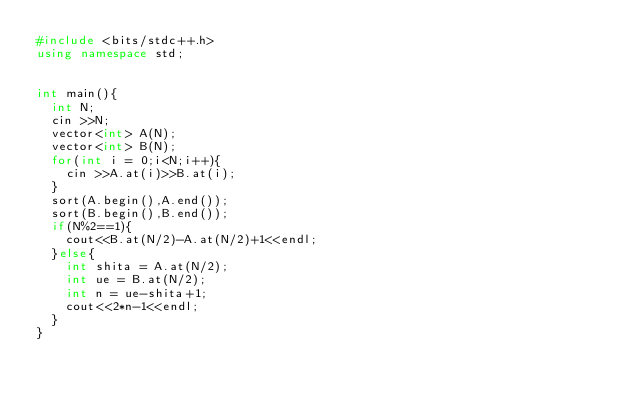Convert code to text. <code><loc_0><loc_0><loc_500><loc_500><_C++_>#include <bits/stdc++.h>
using namespace std;


int main(){
  int N;
  cin >>N;
  vector<int> A(N);
  vector<int> B(N);
  for(int i = 0;i<N;i++){
    cin >>A.at(i)>>B.at(i);
  }
  sort(A.begin(),A.end());
  sort(B.begin(),B.end());
  if(N%2==1){
    cout<<B.at(N/2)-A.at(N/2)+1<<endl;
  }else{
    int shita = A.at(N/2);
    int ue = B.at(N/2);
    int n = ue-shita+1;
    cout<<2*n-1<<endl;
  }
}</code> 